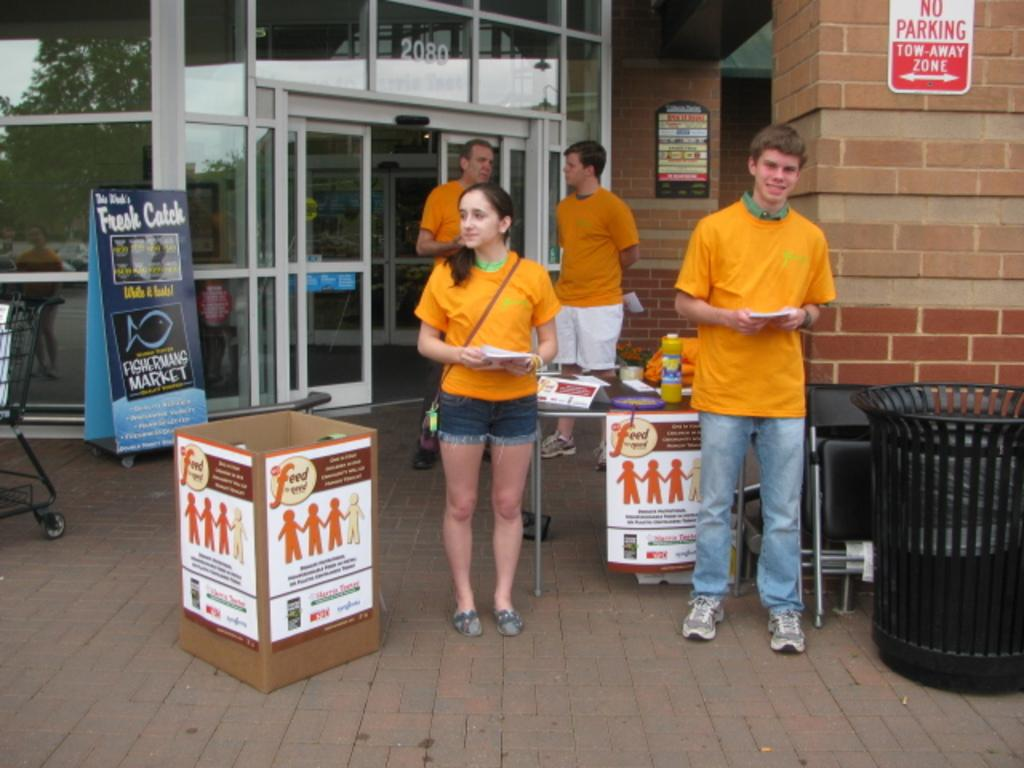Provide a one-sentence caption for the provided image. a two away zone that is behind some people. 